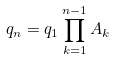<formula> <loc_0><loc_0><loc_500><loc_500>q _ { n } = q _ { 1 } \prod _ { k = 1 } ^ { n - 1 } A _ { k }</formula> 